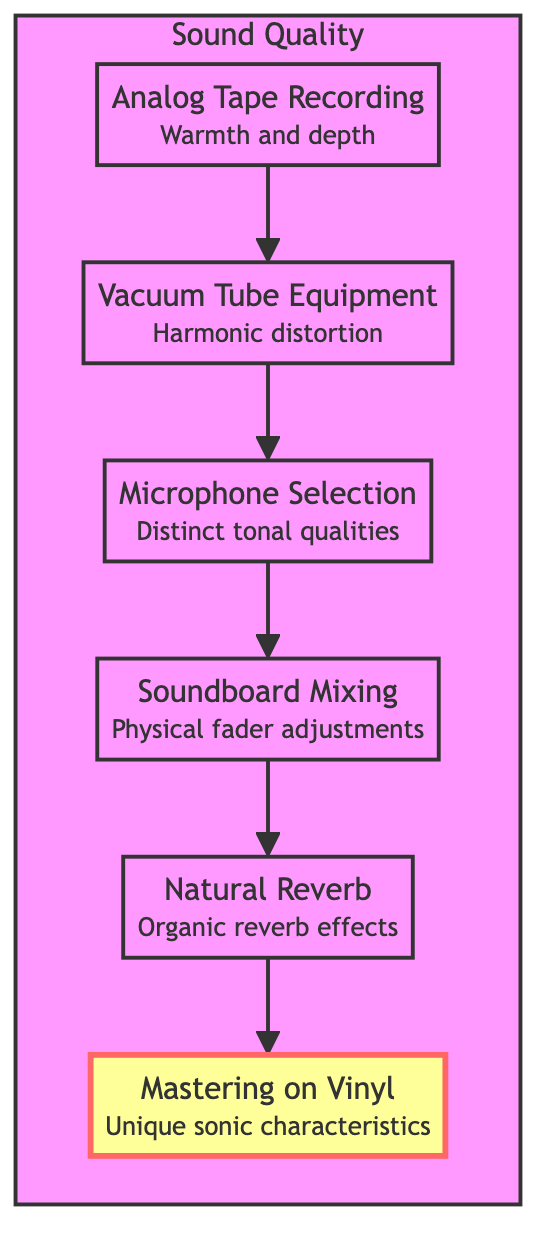What is the first element in the flow chart? The diagram starts with the first node labeled "Analog Tape Recording." This node indicates the initial step in the analog recording process.
Answer: Analog Tape Recording How many elements are in the flow chart? By counting the individual nodes in the diagram, there are a total of six distinct elements represented.
Answer: 6 Which element is connected to "Microphone Selection"? The diagram shows that "Microphone Selection" is connected to "Vacuum Tube Equipment." This indicates it is the preceding step in the flow.
Answer: Vacuum Tube Equipment What impact does "Natural Reverb" have on the sound? The node for "Natural Reverb" describes it as providing "Organic reverb effects," highlighting its qualitative impact on the recording.
Answer: Organic reverb effects What is the final component in the sound quality process? According to the flow chart, the last element forming the pathway is "Mastering on Vinyl." This signifies it as the concluding action.
Answer: Mastering on Vinyl Which element precedes "Soundboard Mixing"? The diagram indicates that "Microphone Selection" immediately precedes "Soundboard Mixing," establishing a direct flow between these steps.
Answer: Microphone Selection How does "Vacuum Tube Equipment" affect the sound? "Vacuum Tube Equipment" is described as enriching sound with "harmonic distortion and saturation," indicating its specific audio enhancement role.
Answer: Harmonic distortion What is the relationship between "Analog Tape Recording" and "Mastering on Vinyl"? The relationship shows a flow from "Analog Tape Recording" to "Mastering on Vinyl," implying a sequential production process starting from recording to final mastering.
Answer: Sequential production process What effect does "Mastering on Vinyl" have on the album? "Mastering on Vinyl" is noted for its "unique sonic characteristics and texture," which describe its specific benefits for the final sound quality.
Answer: Unique sonic characteristics 